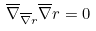<formula> <loc_0><loc_0><loc_500><loc_500>\overline { \nabla } _ { \overline { \nabla } r } \overline { \nabla } r = 0</formula> 